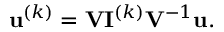Convert formula to latex. <formula><loc_0><loc_0><loc_500><loc_500>u ^ { ( k ) } = V I ^ { ( k ) } V ^ { - 1 } u .</formula> 